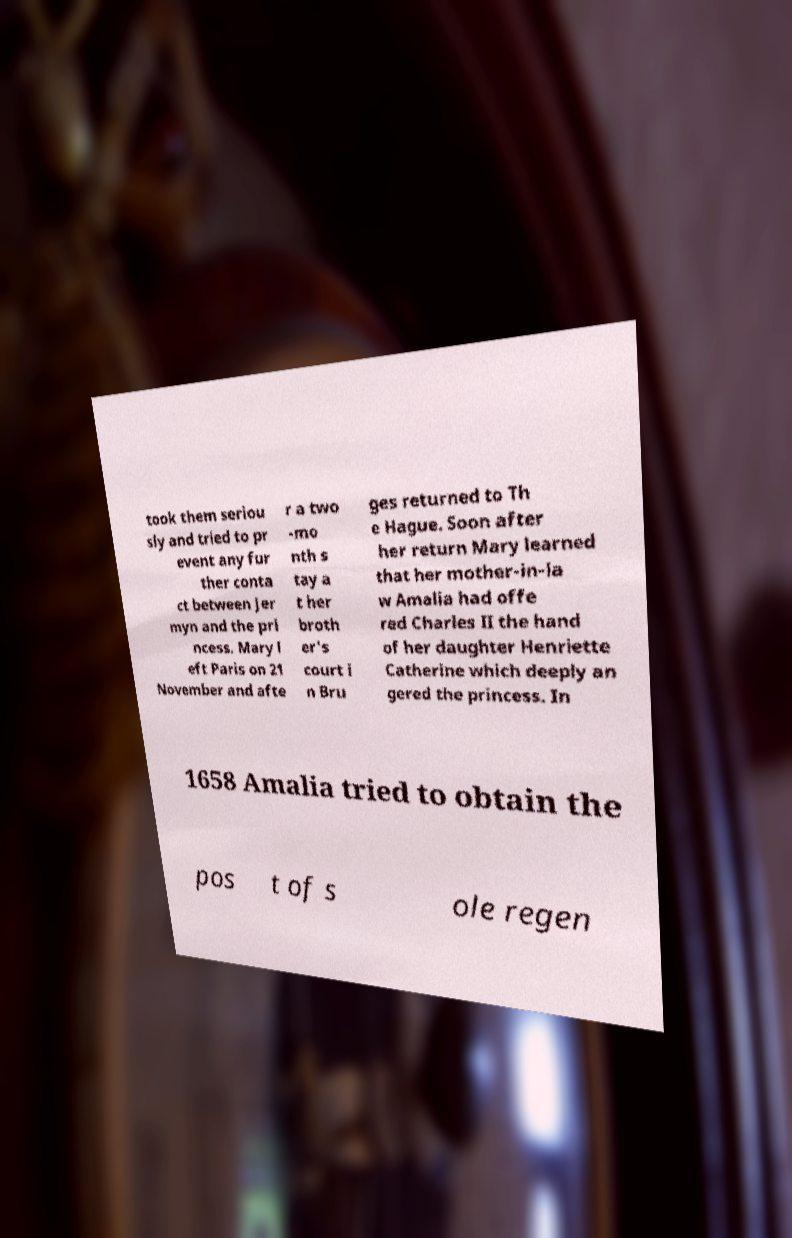Can you accurately transcribe the text from the provided image for me? took them seriou sly and tried to pr event any fur ther conta ct between Jer myn and the pri ncess. Mary l eft Paris on 21 November and afte r a two -mo nth s tay a t her broth er's court i n Bru ges returned to Th e Hague. Soon after her return Mary learned that her mother-in-la w Amalia had offe red Charles II the hand of her daughter Henriette Catherine which deeply an gered the princess. In 1658 Amalia tried to obtain the pos t of s ole regen 